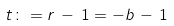<formula> <loc_0><loc_0><loc_500><loc_500>t \colon = r \, - \, 1 = - b \, - \, 1</formula> 